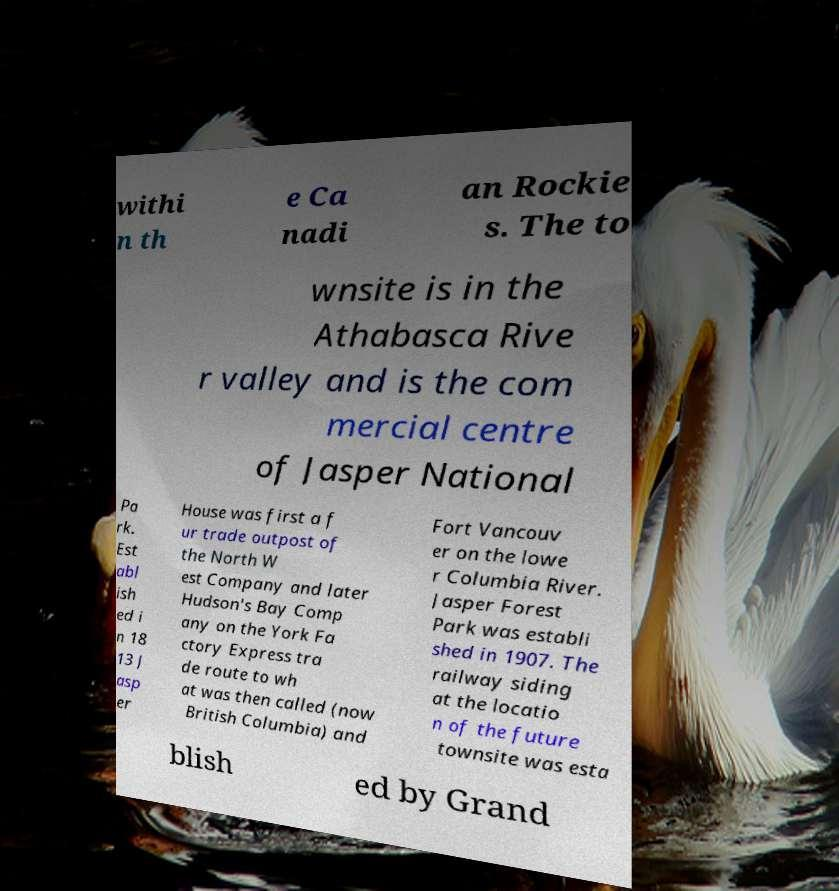Can you read and provide the text displayed in the image?This photo seems to have some interesting text. Can you extract and type it out for me? withi n th e Ca nadi an Rockie s. The to wnsite is in the Athabasca Rive r valley and is the com mercial centre of Jasper National Pa rk. Est abl ish ed i n 18 13 J asp er House was first a f ur trade outpost of the North W est Company and later Hudson's Bay Comp any on the York Fa ctory Express tra de route to wh at was then called (now British Columbia) and Fort Vancouv er on the lowe r Columbia River. Jasper Forest Park was establi shed in 1907. The railway siding at the locatio n of the future townsite was esta blish ed by Grand 